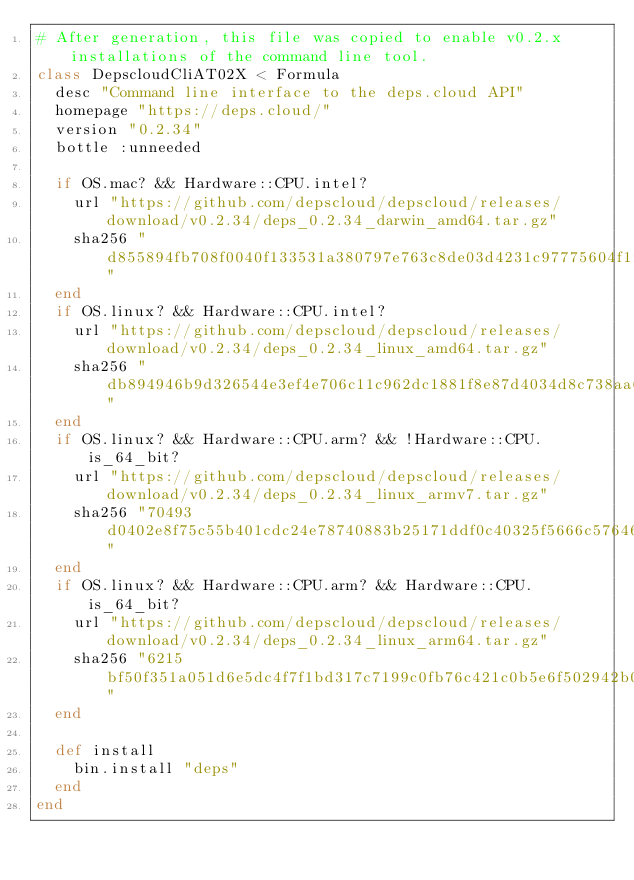<code> <loc_0><loc_0><loc_500><loc_500><_Ruby_># After generation, this file was copied to enable v0.2.x installations of the command line tool.
class DepscloudCliAT02X < Formula
  desc "Command line interface to the deps.cloud API"
  homepage "https://deps.cloud/"
  version "0.2.34"
  bottle :unneeded

  if OS.mac? && Hardware::CPU.intel?
    url "https://github.com/depscloud/depscloud/releases/download/v0.2.34/deps_0.2.34_darwin_amd64.tar.gz"
    sha256 "d855894fb708f0040f133531a380797e763c8de03d4231c97775604f12b9a1fe"
  end
  if OS.linux? && Hardware::CPU.intel?
    url "https://github.com/depscloud/depscloud/releases/download/v0.2.34/deps_0.2.34_linux_amd64.tar.gz"
    sha256 "db894946b9d326544e3ef4e706c11c962dc1881f8e87d4034d8c738aa634fb18"
  end
  if OS.linux? && Hardware::CPU.arm? && !Hardware::CPU.is_64_bit?
    url "https://github.com/depscloud/depscloud/releases/download/v0.2.34/deps_0.2.34_linux_armv7.tar.gz"
    sha256 "70493d0402e8f75c55b401cdc24e78740883b25171ddf0c40325f5666c57646d"
  end
  if OS.linux? && Hardware::CPU.arm? && Hardware::CPU.is_64_bit?
    url "https://github.com/depscloud/depscloud/releases/download/v0.2.34/deps_0.2.34_linux_arm64.tar.gz"
    sha256 "6215bf50f351a051d6e5dc4f7f1bd317c7199c0fb76c421c0b5e6f502942b066"
  end

  def install
    bin.install "deps"
  end
end
</code> 